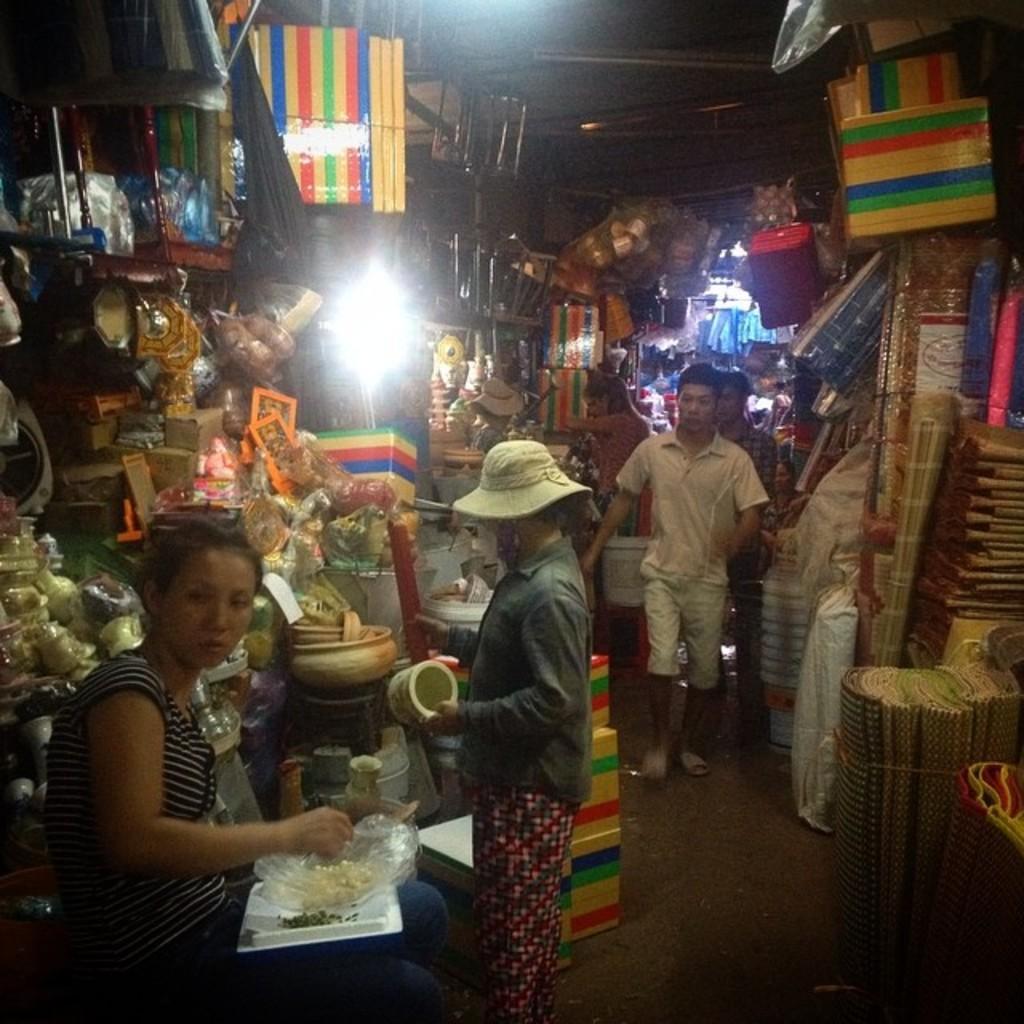Describe this image in one or two sentences. This picture might be taken in a market, in this image there are some stores and in the stores there are some baskets, pots and some other objects. And there are some persons who are walking, and some of them are buying something. At the bottom there is a walkway, on the left side there is one woman who is sitting and she is holding a cover and some object and also in the background there are some lights. 